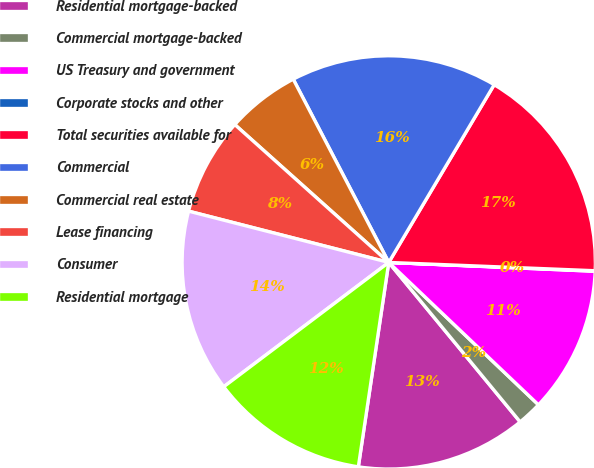Convert chart. <chart><loc_0><loc_0><loc_500><loc_500><pie_chart><fcel>Residential mortgage-backed<fcel>Commercial mortgage-backed<fcel>US Treasury and government<fcel>Corporate stocks and other<fcel>Total securities available for<fcel>Commercial<fcel>Commercial real estate<fcel>Lease financing<fcel>Consumer<fcel>Residential mortgage<nl><fcel>13.32%<fcel>1.93%<fcel>11.42%<fcel>0.04%<fcel>17.12%<fcel>16.17%<fcel>5.73%<fcel>7.63%<fcel>14.27%<fcel>12.37%<nl></chart> 